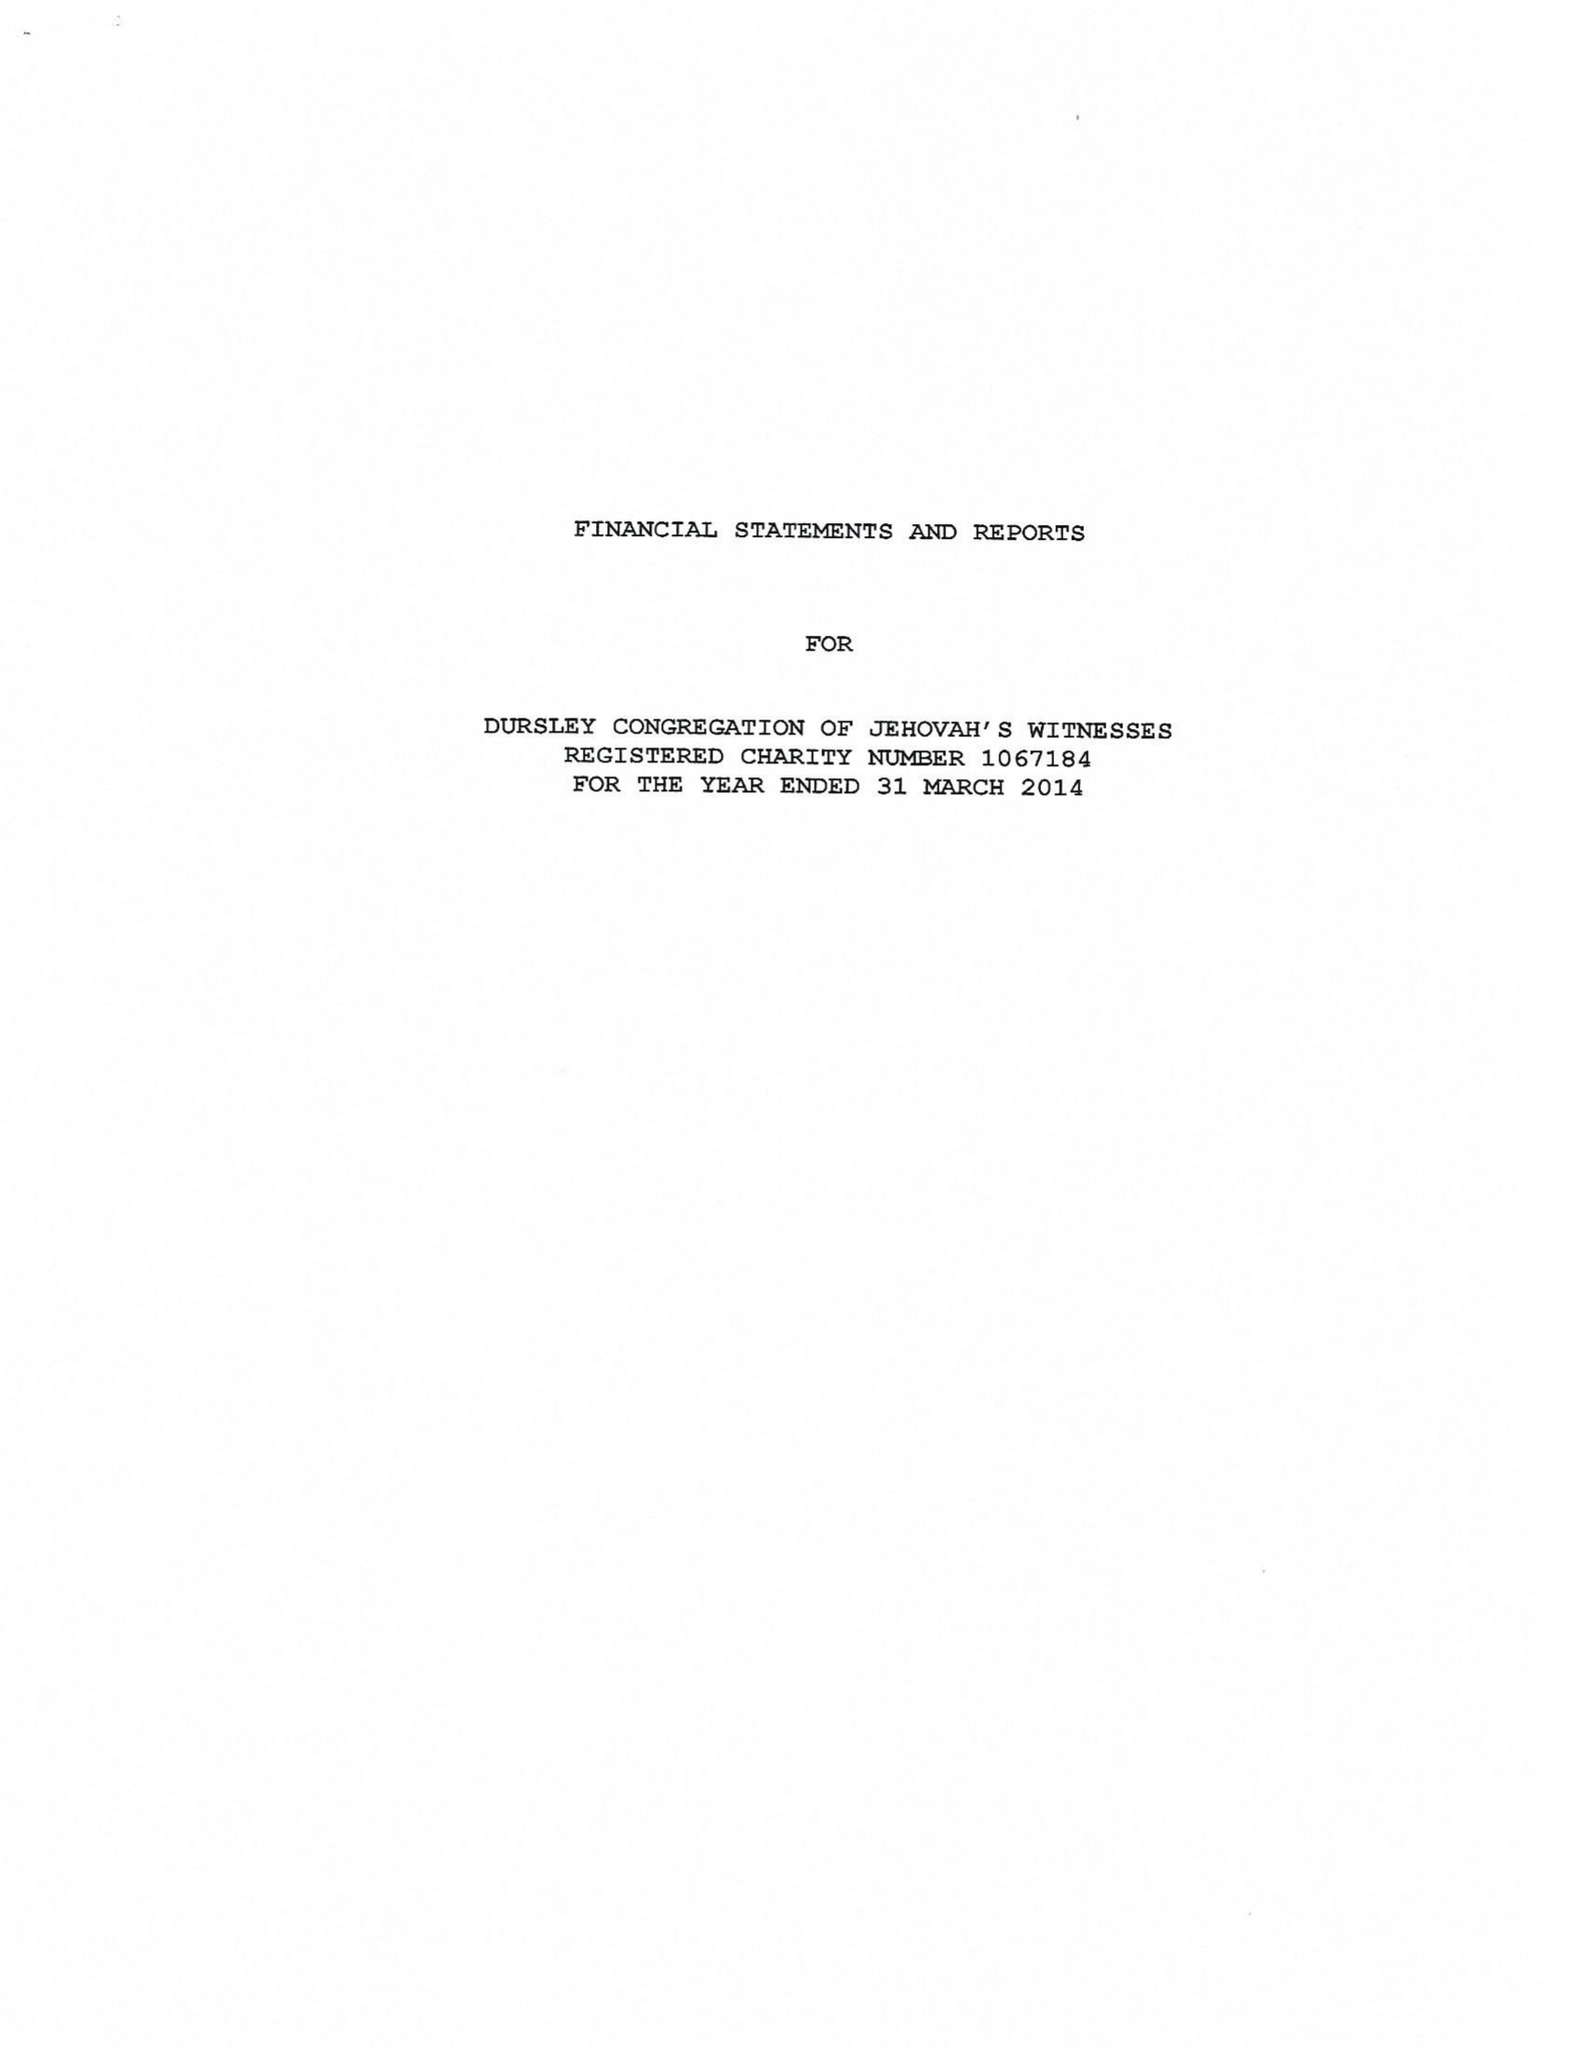What is the value for the charity_number?
Answer the question using a single word or phrase. 1067184 